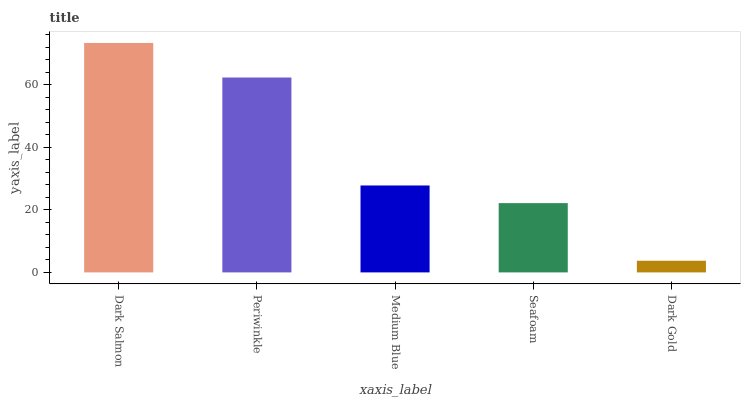Is Dark Gold the minimum?
Answer yes or no. Yes. Is Dark Salmon the maximum?
Answer yes or no. Yes. Is Periwinkle the minimum?
Answer yes or no. No. Is Periwinkle the maximum?
Answer yes or no. No. Is Dark Salmon greater than Periwinkle?
Answer yes or no. Yes. Is Periwinkle less than Dark Salmon?
Answer yes or no. Yes. Is Periwinkle greater than Dark Salmon?
Answer yes or no. No. Is Dark Salmon less than Periwinkle?
Answer yes or no. No. Is Medium Blue the high median?
Answer yes or no. Yes. Is Medium Blue the low median?
Answer yes or no. Yes. Is Seafoam the high median?
Answer yes or no. No. Is Dark Gold the low median?
Answer yes or no. No. 